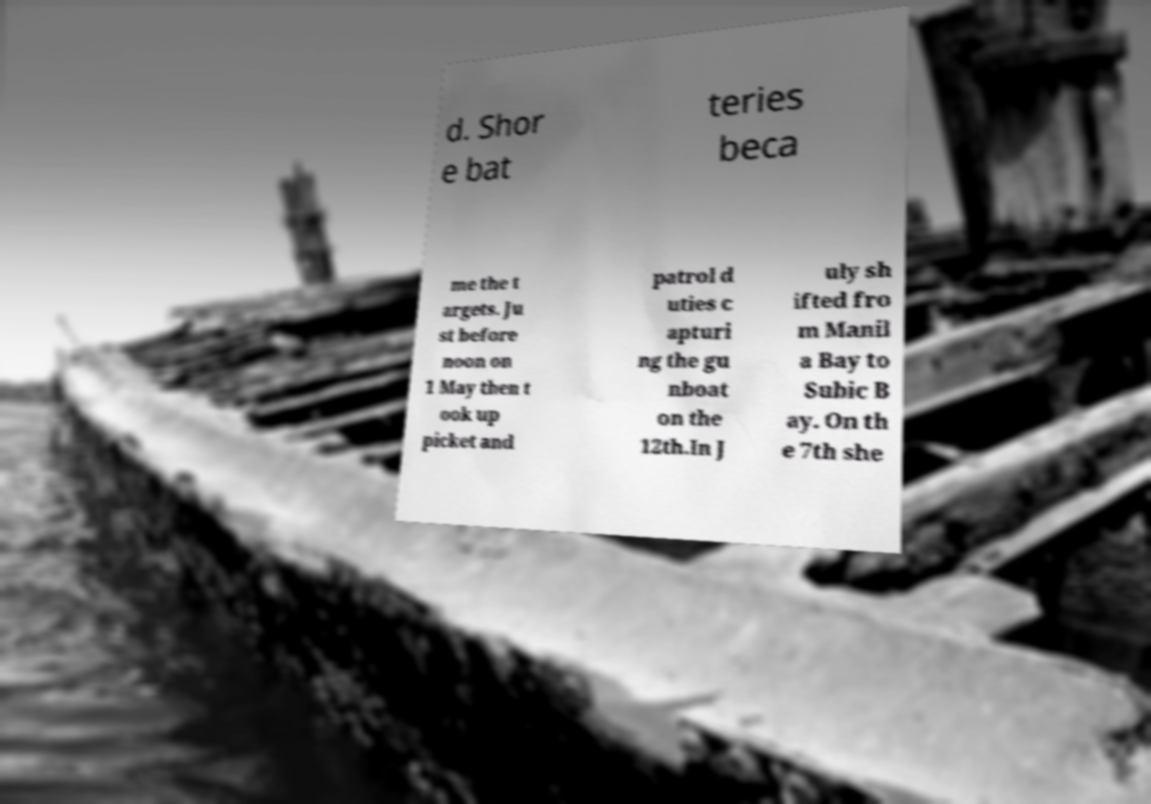Please identify and transcribe the text found in this image. d. Shor e bat teries beca me the t argets. Ju st before noon on 1 May then t ook up picket and patrol d uties c apturi ng the gu nboat on the 12th.In J uly sh ifted fro m Manil a Bay to Subic B ay. On th e 7th she 